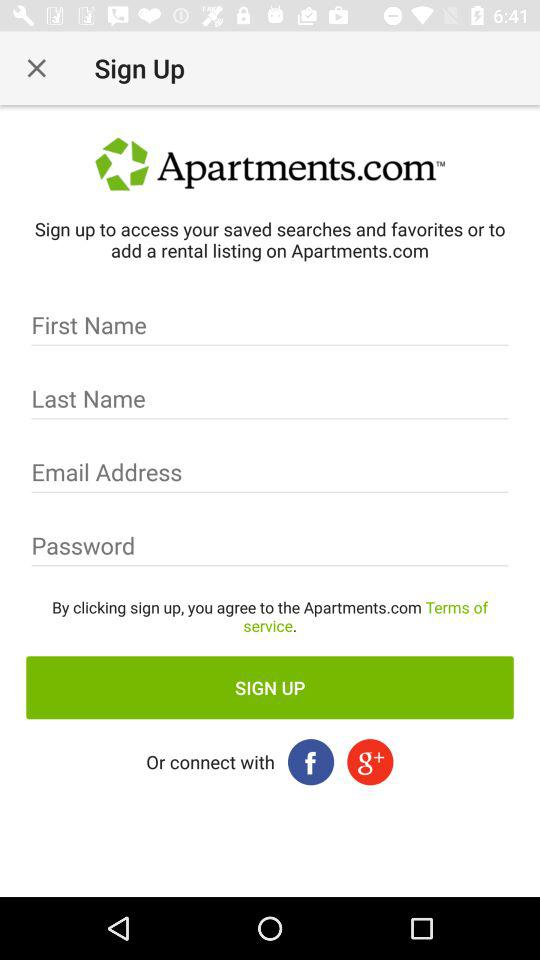What are the different options to connect? The different options to connect are: "Facebook" and "Google+". 